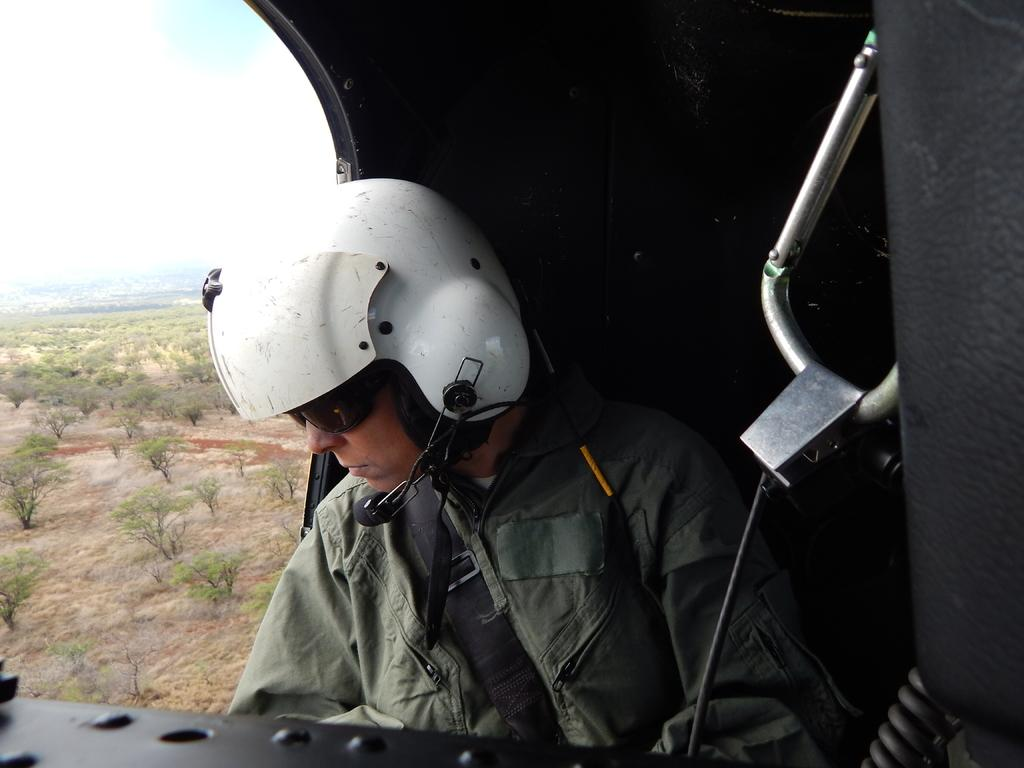What is the main subject of the image? There is a person in the image. What is the person wearing? The person is wearing clothes, a helmet, and goggles. What is the person doing in the image? The person is sitting. What can be seen in the background of the image? There is a flying jet, a tree, grass, and the sky visible in the image. What type of office can be seen in the image? There is no office present in the image. How many planes are visible in the image? There is only one flying jet visible in the image. Is there a ghost present in the image? There is no ghost present in the image. 